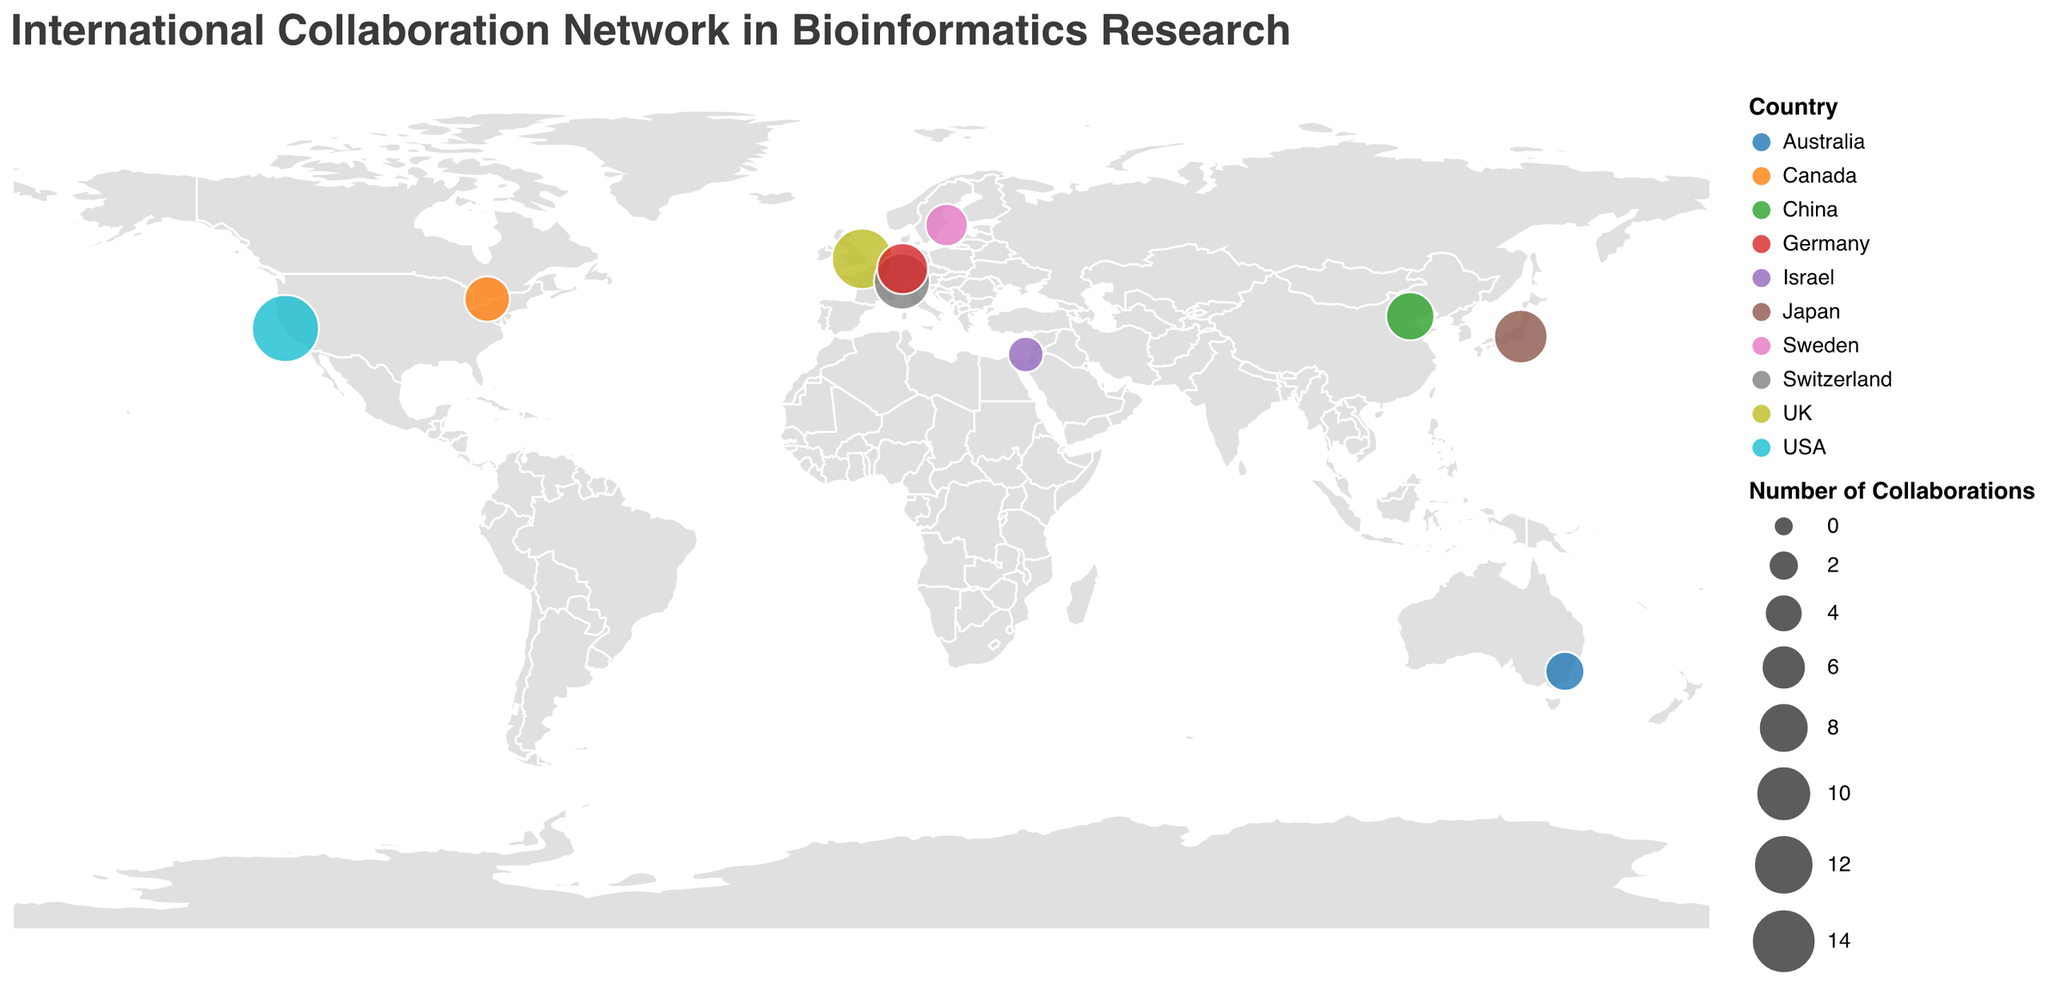How many institutions are represented in the figure? Count the total number of circles represent different institutions in the figure.
Answer: 10 Which institution has the most number of collaborations? Identify the circle with the largest size and hover over to reveal the tooltip which includes the "Institution" and "Collaborations" information.
Answer: Stanford University What is the total number of collaborations from institutions in Europe? Summing up the collaborations from institutions in UK (12), Switzerland (10), Germany (8), and Sweden (5).
Answer: 35 Which country has the highest number of represented institutions? Observe the colors representing different countries and count the number of institutions for each.
Answer: USA Compare the number of collaborations between Tsinghua University and University of Toronto. Which has more? Check the size of the circles and hover over them for detailed collaboration numbers.
Answer: Tsinghua University What is the average number of collaborations among all the institutions? Sum the collaborations (15+12+10+9+8+7+6+5+4+3 = 79) and divide by the number of institutions (79/10).
Answer: 7.9 Which institution is located furthest south? Check the latitude values and pick the institution with the lowest latitude.
Answer: Australian National University How many institutions are located in the Asia-Pacific region? Identify the circles located in Asia and the Pacific (China, Japan, Australia).
Answer: 3 What is the median number of collaborations among these institutions? List the collaborations (3, 4, 5, 6, 7, 8, 9, 10, 12, 15), the median is the middle value when the numbers are ordered.
Answer: 7.5 Which institutions are closest to each other geographically? Find circles that are nearest on the map, specifically compare the coordinates.
Answer: Max Planck Institute for Biophysics, ETH Zurich 